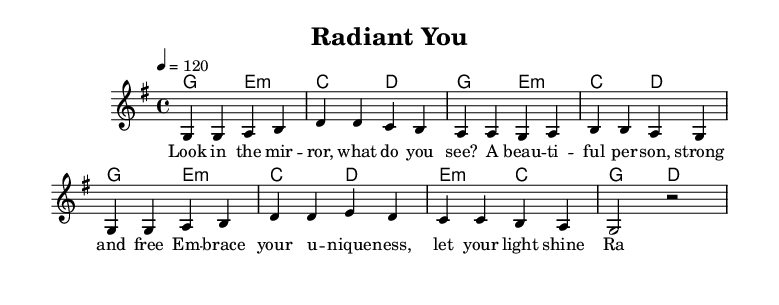what is the key signature of this music? The key signature is G major, indicated by one sharp (F#). It is identified by looking at the beginning of the score, where the sharp is noted, signifying that the piece is in G major.
Answer: G major what is the time signature of this music? The time signature is 4/4, which means there are four beats in each measure and the quarter note receives one beat. This is clearly indicated at the beginning of the score.
Answer: 4/4 what is the tempo marking for this music? The tempo marking is 120 beats per minute, specified in the score with the tempo directive "4 = 120". This indicates the speed at which the piece should be performed.
Answer: 120 how many bars are in the verse? The verse consists of four bars, as indicated by the grouping of the measures in the sheet music. Each grouping represents a complete measure, and counting those yields four.
Answer: four which chord follows the E minor chord in the harmony? The chord following the E minor chord in the harmony is C major, which appears immediately after E minor in the harmonic progression shown in the score.
Answer: C major what is the main theme described in the lyrics? The main theme described in the lyrics is self-confidence and beauty, where the lyrics encourage embracing uniqueness and radiance. This can be inferred from the phrases used that emphasize self-love and appreciation.
Answer: self-confidence and beauty what does the phrase "radiant you" emphasize in the context of the song? The phrase "radiant you" emphasizes self-acceptance and shining one's own light. This phrase is central to the message of the lyrics, which focuses on beauty and confidence in being oneself.
Answer: self-acceptance 